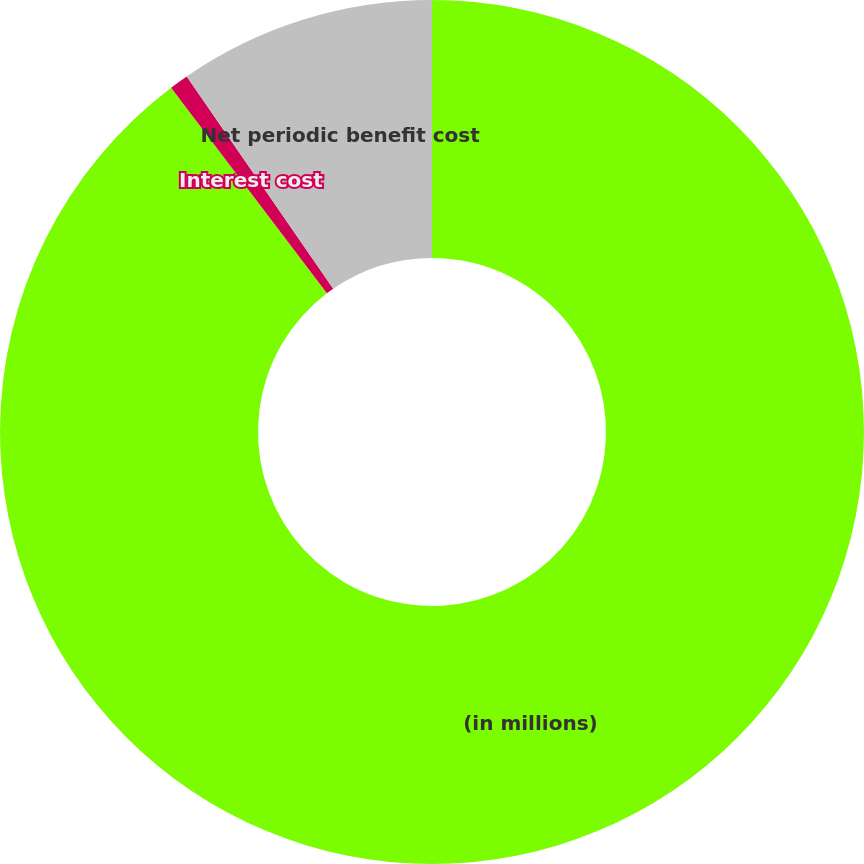<chart> <loc_0><loc_0><loc_500><loc_500><pie_chart><fcel>(in millions)<fcel>Interest cost<fcel>Net periodic benefit cost<nl><fcel>89.68%<fcel>0.71%<fcel>9.61%<nl></chart> 